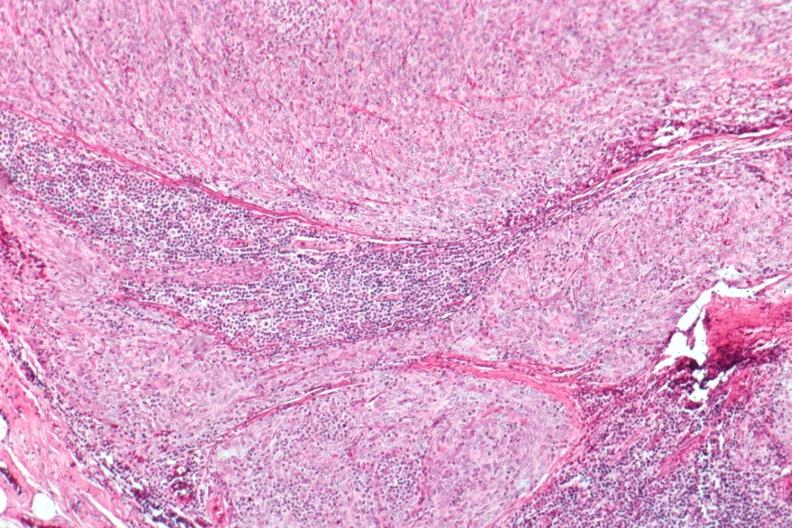s thyroid present?
Answer the question using a single word or phrase. No 